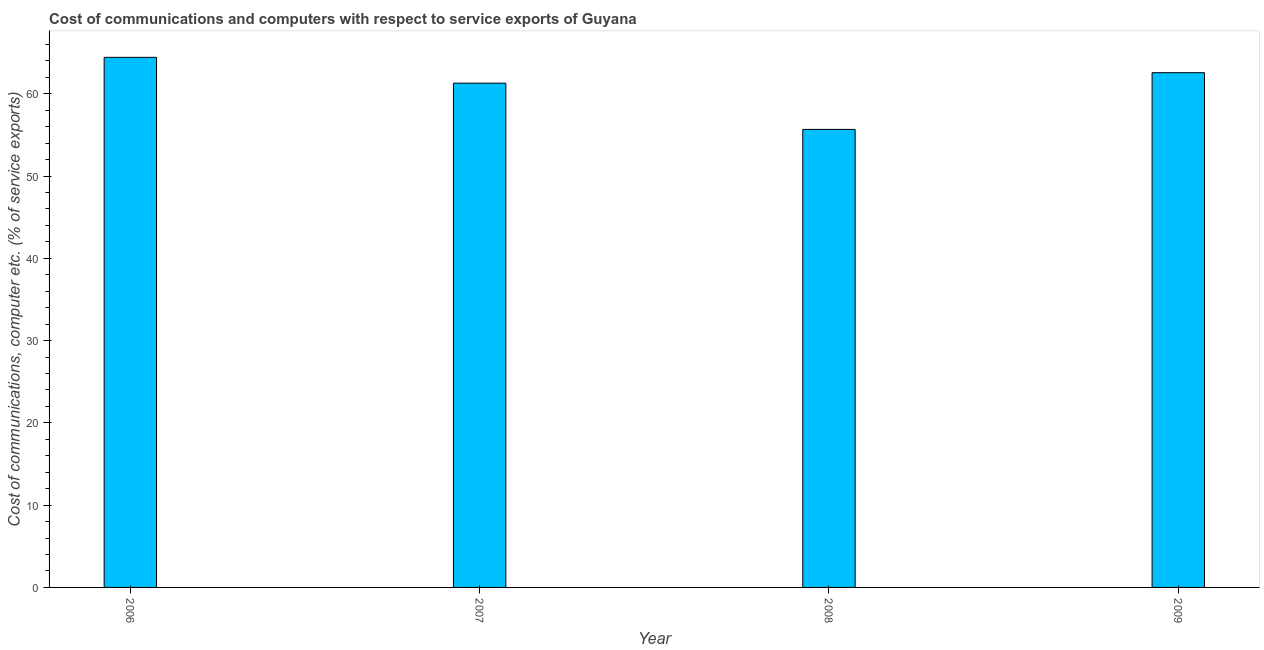Does the graph contain any zero values?
Ensure brevity in your answer.  No. What is the title of the graph?
Give a very brief answer. Cost of communications and computers with respect to service exports of Guyana. What is the label or title of the X-axis?
Provide a short and direct response. Year. What is the label or title of the Y-axis?
Provide a short and direct response. Cost of communications, computer etc. (% of service exports). What is the cost of communications and computer in 2007?
Offer a very short reply. 61.28. Across all years, what is the maximum cost of communications and computer?
Your answer should be compact. 64.42. Across all years, what is the minimum cost of communications and computer?
Provide a short and direct response. 55.66. In which year was the cost of communications and computer maximum?
Provide a succinct answer. 2006. What is the sum of the cost of communications and computer?
Offer a very short reply. 243.92. What is the difference between the cost of communications and computer in 2007 and 2008?
Keep it short and to the point. 5.62. What is the average cost of communications and computer per year?
Keep it short and to the point. 60.98. What is the median cost of communications and computer?
Give a very brief answer. 61.92. Do a majority of the years between 2008 and 2009 (inclusive) have cost of communications and computer greater than 62 %?
Give a very brief answer. No. What is the ratio of the cost of communications and computer in 2006 to that in 2007?
Ensure brevity in your answer.  1.05. Is the cost of communications and computer in 2007 less than that in 2008?
Provide a succinct answer. No. Is the difference between the cost of communications and computer in 2006 and 2007 greater than the difference between any two years?
Your answer should be compact. No. What is the difference between the highest and the second highest cost of communications and computer?
Offer a very short reply. 1.87. What is the difference between the highest and the lowest cost of communications and computer?
Give a very brief answer. 8.76. How many bars are there?
Give a very brief answer. 4. What is the difference between two consecutive major ticks on the Y-axis?
Keep it short and to the point. 10. Are the values on the major ticks of Y-axis written in scientific E-notation?
Offer a terse response. No. What is the Cost of communications, computer etc. (% of service exports) in 2006?
Offer a terse response. 64.42. What is the Cost of communications, computer etc. (% of service exports) of 2007?
Provide a succinct answer. 61.28. What is the Cost of communications, computer etc. (% of service exports) in 2008?
Make the answer very short. 55.66. What is the Cost of communications, computer etc. (% of service exports) in 2009?
Provide a succinct answer. 62.55. What is the difference between the Cost of communications, computer etc. (% of service exports) in 2006 and 2007?
Your answer should be compact. 3.14. What is the difference between the Cost of communications, computer etc. (% of service exports) in 2006 and 2008?
Make the answer very short. 8.76. What is the difference between the Cost of communications, computer etc. (% of service exports) in 2006 and 2009?
Offer a terse response. 1.87. What is the difference between the Cost of communications, computer etc. (% of service exports) in 2007 and 2008?
Your response must be concise. 5.62. What is the difference between the Cost of communications, computer etc. (% of service exports) in 2007 and 2009?
Provide a succinct answer. -1.27. What is the difference between the Cost of communications, computer etc. (% of service exports) in 2008 and 2009?
Keep it short and to the point. -6.89. What is the ratio of the Cost of communications, computer etc. (% of service exports) in 2006 to that in 2007?
Your answer should be compact. 1.05. What is the ratio of the Cost of communications, computer etc. (% of service exports) in 2006 to that in 2008?
Your response must be concise. 1.16. What is the ratio of the Cost of communications, computer etc. (% of service exports) in 2007 to that in 2008?
Keep it short and to the point. 1.1. What is the ratio of the Cost of communications, computer etc. (% of service exports) in 2008 to that in 2009?
Make the answer very short. 0.89. 